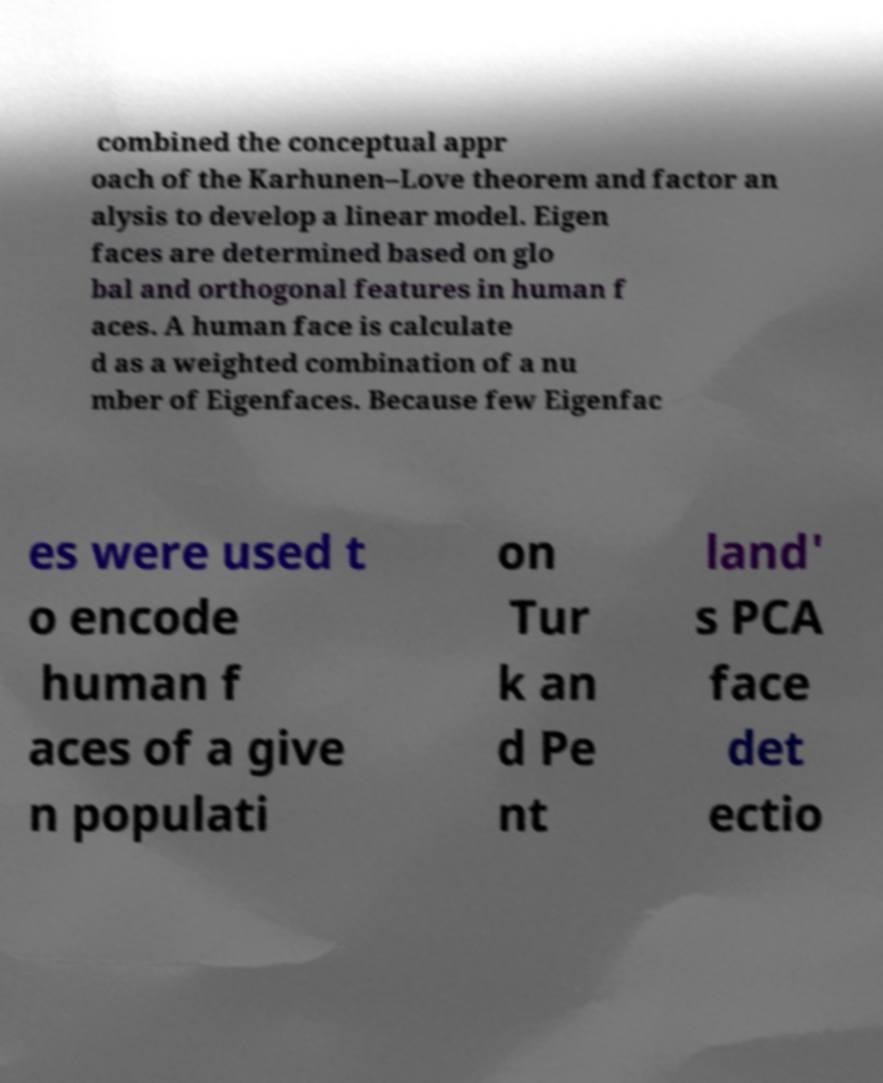I need the written content from this picture converted into text. Can you do that? combined the conceptual appr oach of the Karhunen–Love theorem and factor an alysis to develop a linear model. Eigen faces are determined based on glo bal and orthogonal features in human f aces. A human face is calculate d as a weighted combination of a nu mber of Eigenfaces. Because few Eigenfac es were used t o encode human f aces of a give n populati on Tur k an d Pe nt land' s PCA face det ectio 